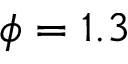Convert formula to latex. <formula><loc_0><loc_0><loc_500><loc_500>\phi = 1 . 3</formula> 